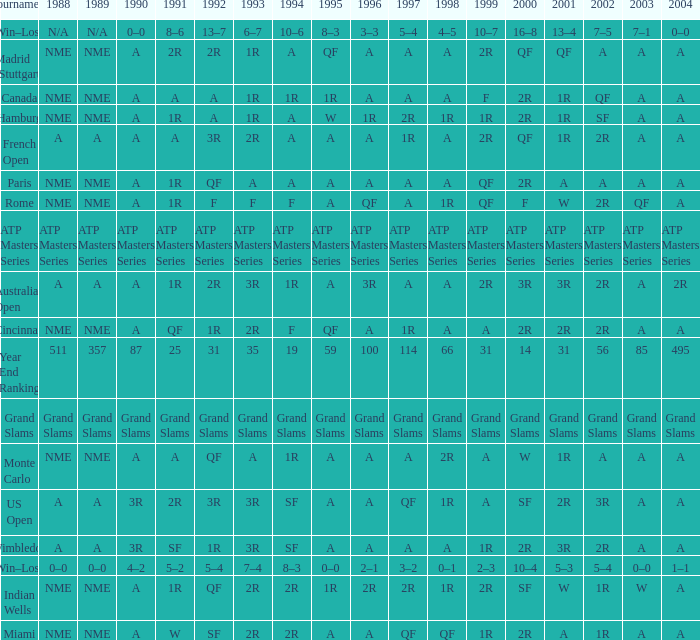What shows for 1992 when 1988 is A, at the Australian Open? 2R. 